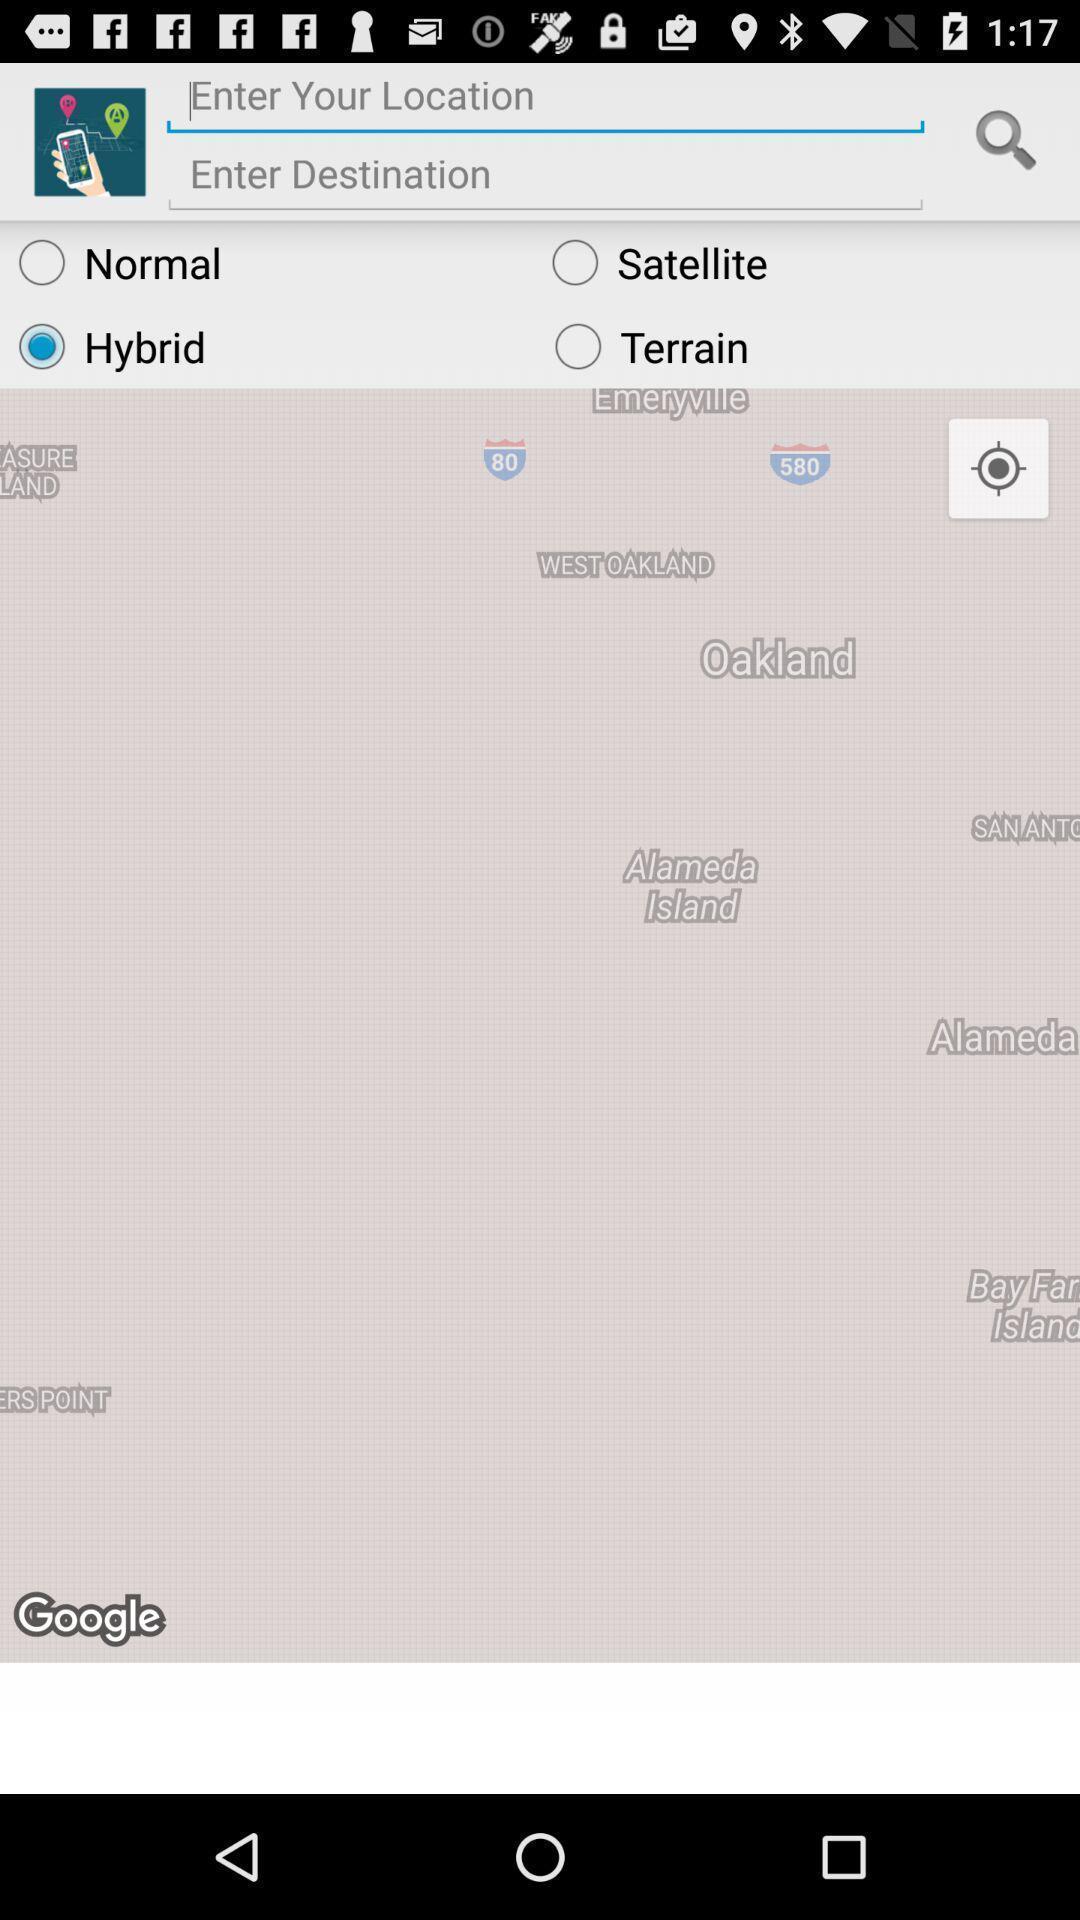Summarize the main components in this picture. Page to enter location and search destination on the map. 